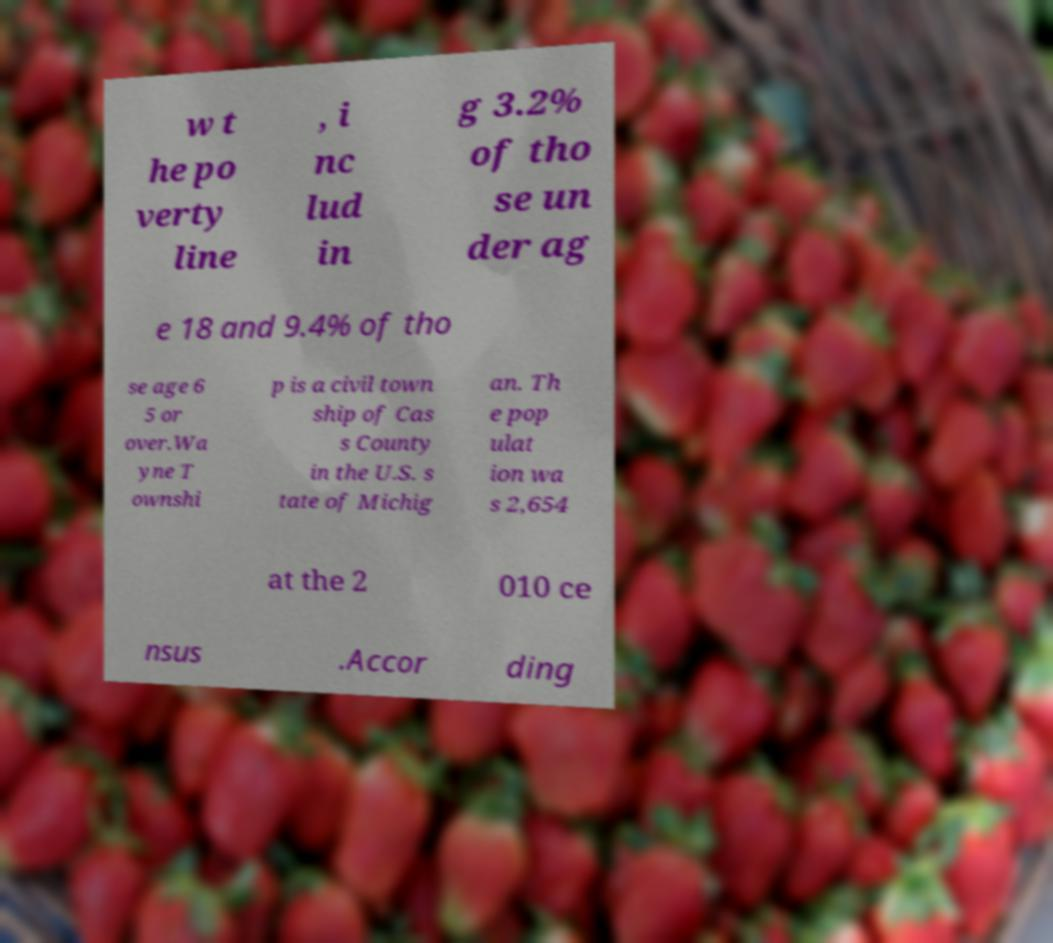What messages or text are displayed in this image? I need them in a readable, typed format. w t he po verty line , i nc lud in g 3.2% of tho se un der ag e 18 and 9.4% of tho se age 6 5 or over.Wa yne T ownshi p is a civil town ship of Cas s County in the U.S. s tate of Michig an. Th e pop ulat ion wa s 2,654 at the 2 010 ce nsus .Accor ding 